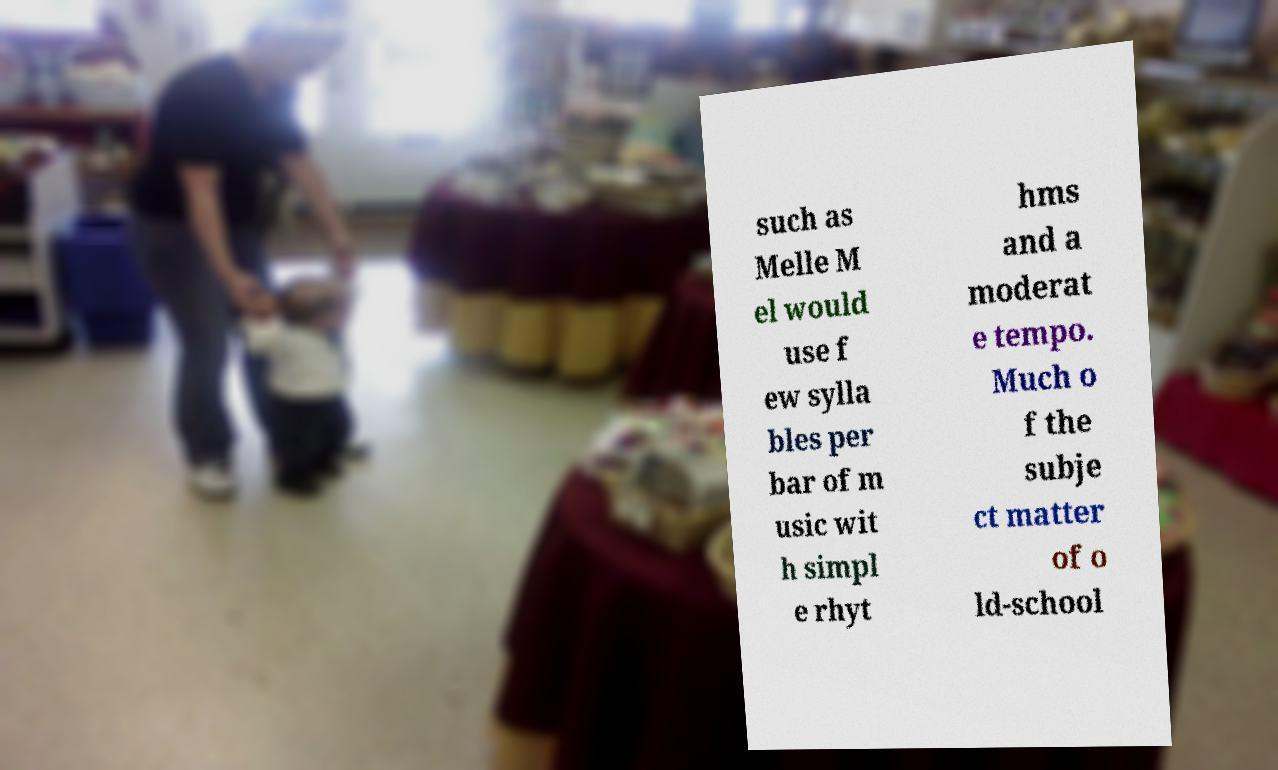Can you read and provide the text displayed in the image?This photo seems to have some interesting text. Can you extract and type it out for me? such as Melle M el would use f ew sylla bles per bar of m usic wit h simpl e rhyt hms and a moderat e tempo. Much o f the subje ct matter of o ld-school 